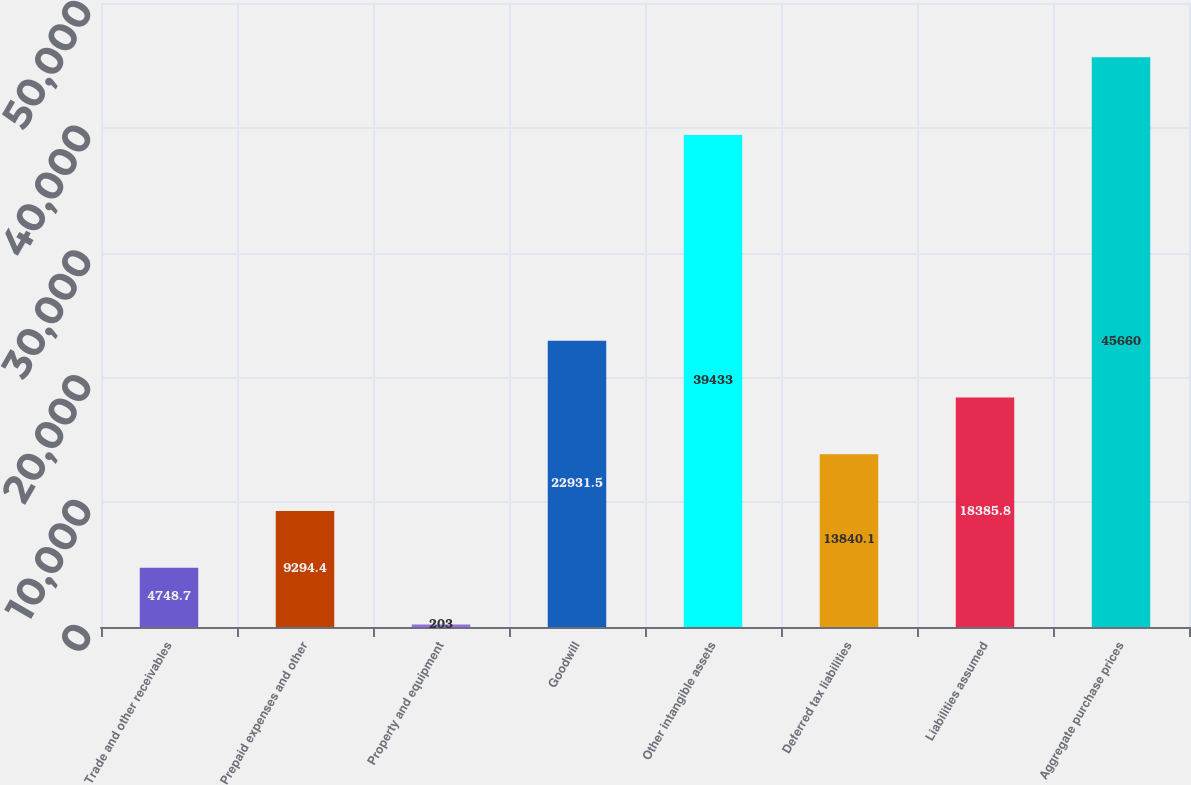<chart> <loc_0><loc_0><loc_500><loc_500><bar_chart><fcel>Trade and other receivables<fcel>Prepaid expenses and other<fcel>Property and equipment<fcel>Goodwill<fcel>Other intangible assets<fcel>Deferred tax liabilities<fcel>Liabilities assumed<fcel>Aggregate purchase prices<nl><fcel>4748.7<fcel>9294.4<fcel>203<fcel>22931.5<fcel>39433<fcel>13840.1<fcel>18385.8<fcel>45660<nl></chart> 